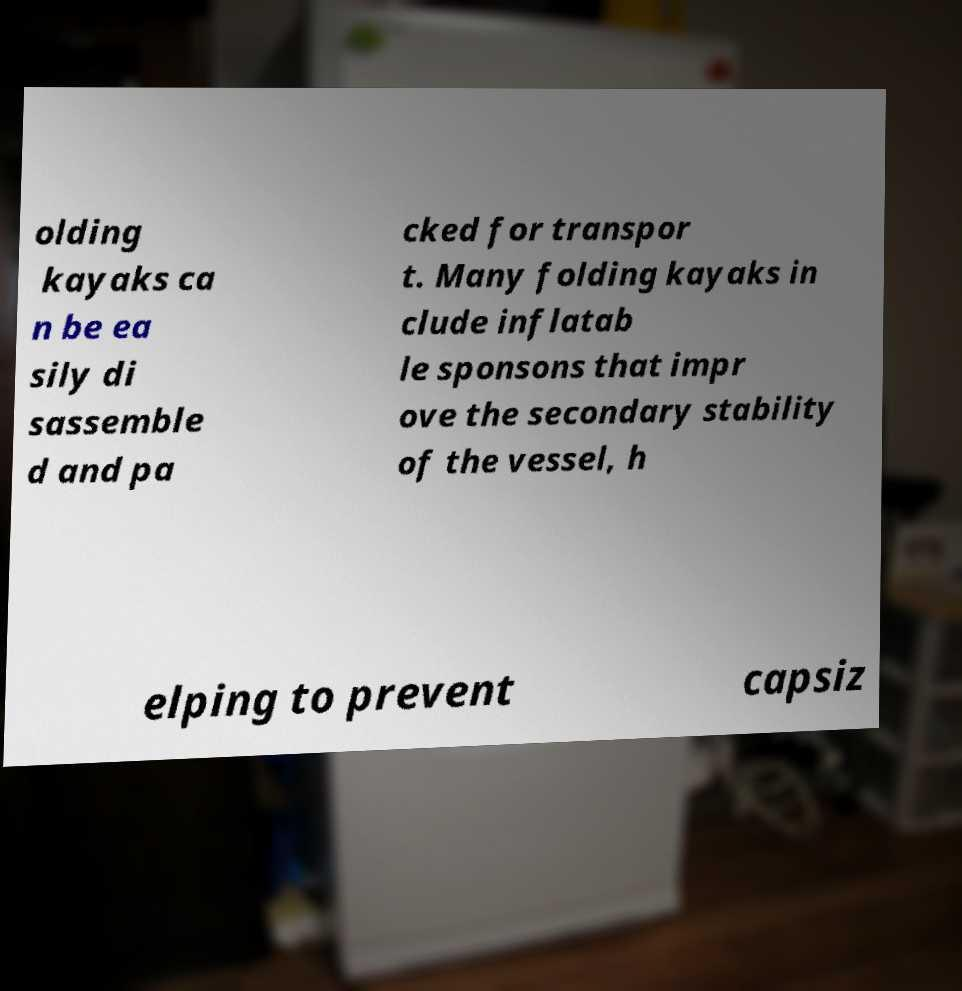Can you accurately transcribe the text from the provided image for me? olding kayaks ca n be ea sily di sassemble d and pa cked for transpor t. Many folding kayaks in clude inflatab le sponsons that impr ove the secondary stability of the vessel, h elping to prevent capsiz 